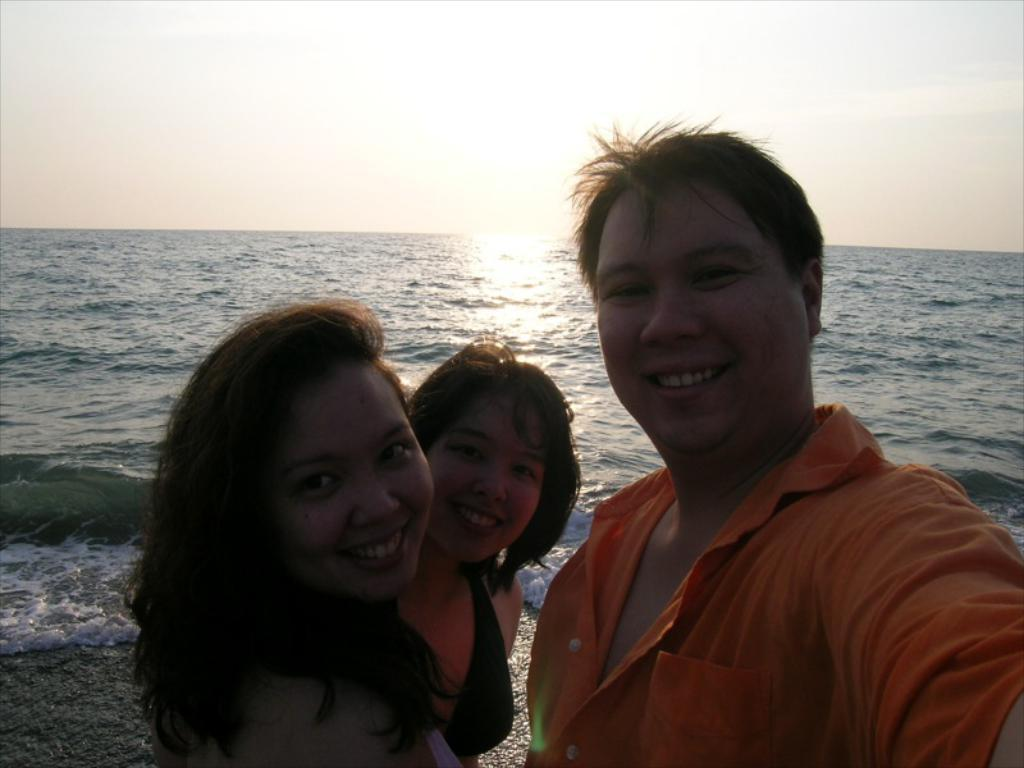How many people are in the image? There are three people in the image. Where are the people located in the image? The people are standing near the sea. What can be seen in the background of the image? The sky is visible in the background of the image. What type of fear can be seen on the faces of the people in the image? There is no indication of fear on the faces of the people in the image. Can you tell me where the cemetery is located in the image? There is no cemetery present in the image; it features three people standing near the sea. 